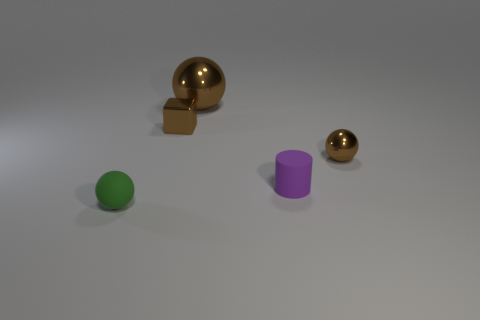Add 2 large shiny objects. How many objects exist? 7 Subtract all blocks. How many objects are left? 4 Subtract 2 brown balls. How many objects are left? 3 Subtract all small brown blocks. Subtract all small matte balls. How many objects are left? 3 Add 5 large metal balls. How many large metal balls are left? 6 Add 1 small brown shiny blocks. How many small brown shiny blocks exist? 2 